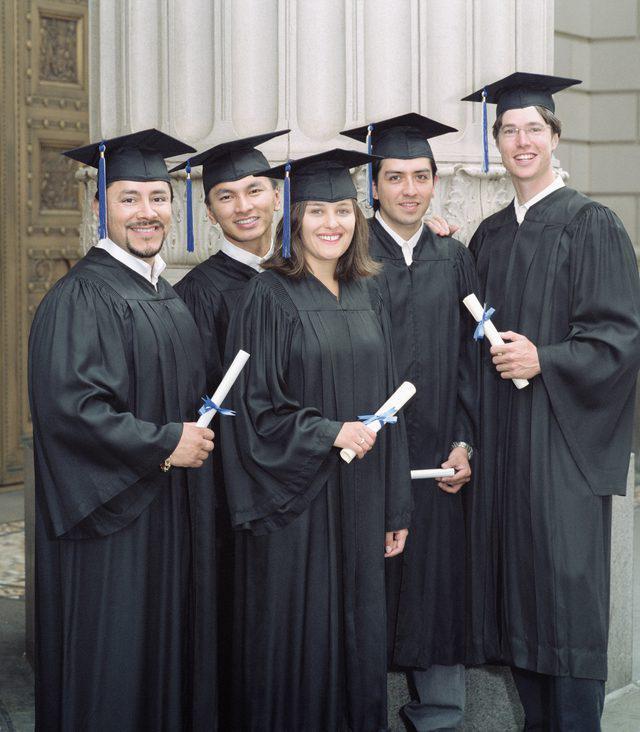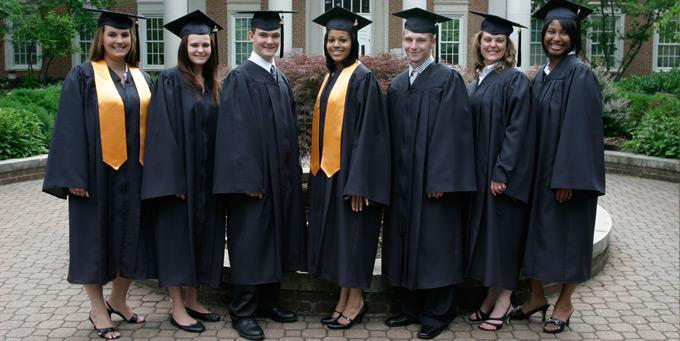The first image is the image on the left, the second image is the image on the right. Examine the images to the left and right. Is the description "There are 8 graduates in both images." accurate? Answer yes or no. No. The first image is the image on the left, the second image is the image on the right. Considering the images on both sides, is "One of the images shows only female graduating students." valid? Answer yes or no. No. 